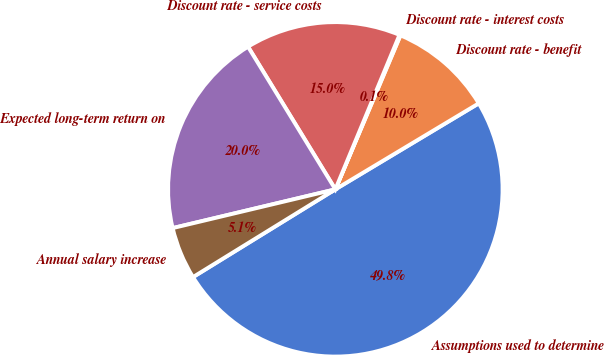<chart> <loc_0><loc_0><loc_500><loc_500><pie_chart><fcel>Assumptions used to determine<fcel>Discount rate - benefit<fcel>Discount rate - interest costs<fcel>Discount rate - service costs<fcel>Expected long-term return on<fcel>Annual salary increase<nl><fcel>49.81%<fcel>10.04%<fcel>0.1%<fcel>15.01%<fcel>19.98%<fcel>5.07%<nl></chart> 